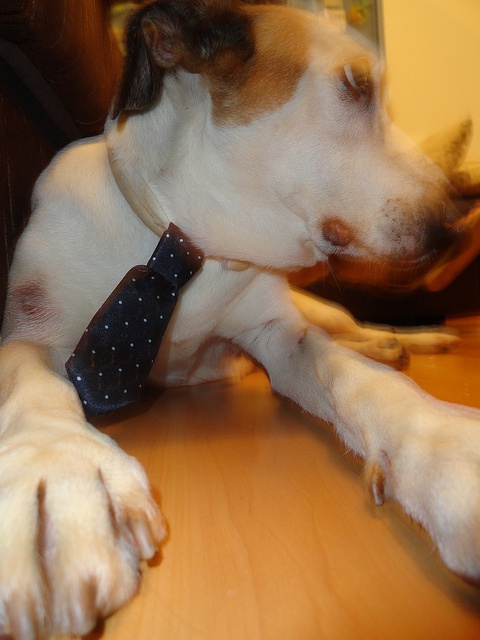Describe the objects in this image and their specific colors. I can see dog in black, darkgray, tan, and gray tones and tie in black, maroon, darkgray, and gray tones in this image. 